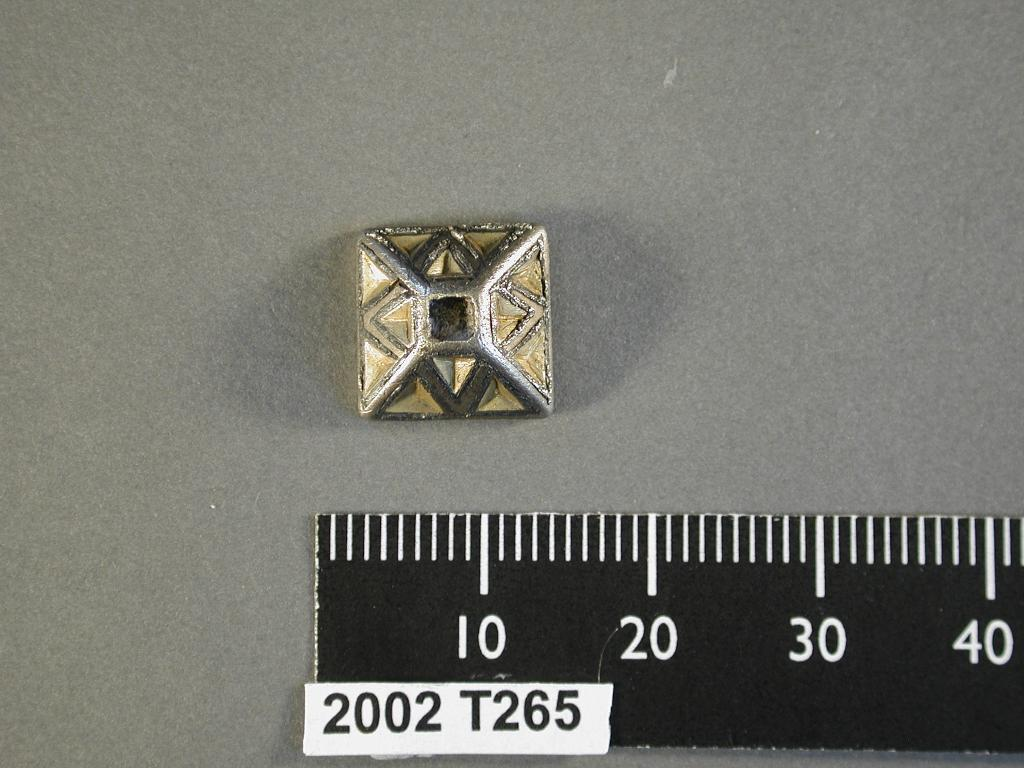<image>
Render a clear and concise summary of the photo. A ruler is labeled with a sticker that reads 2002 T265. 